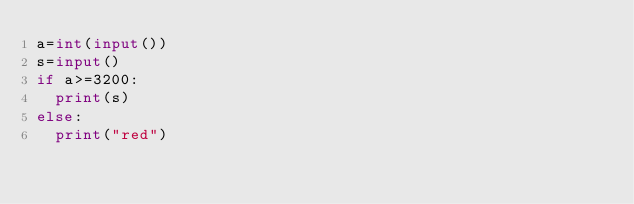Convert code to text. <code><loc_0><loc_0><loc_500><loc_500><_Python_>a=int(input())
s=input()
if a>=3200:
  print(s)
else:
  print("red")</code> 